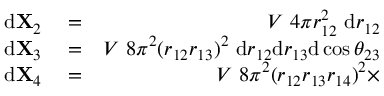Convert formula to latex. <formula><loc_0><loc_0><loc_500><loc_500>\begin{array} { r l r } { d X _ { 2 } } & = } & { V 4 \pi r _ { 1 2 } ^ { 2 } d r _ { 1 2 } } \\ { d X _ { 3 } } & = } & { V 8 \pi ^ { 2 } ( r _ { 1 2 } r _ { 1 3 } ) ^ { 2 } d r _ { 1 2 } d r _ { 1 3 } d \cos \theta _ { 2 3 } } \\ { d X _ { 4 } } & = } & { V 8 \pi ^ { 2 } ( r _ { 1 2 } r _ { 1 3 } r _ { 1 4 } ) ^ { 2 } \times } \end{array}</formula> 